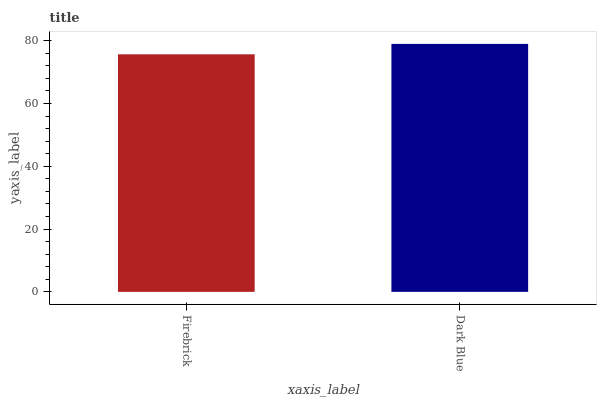Is Firebrick the minimum?
Answer yes or no. Yes. Is Dark Blue the maximum?
Answer yes or no. Yes. Is Dark Blue the minimum?
Answer yes or no. No. Is Dark Blue greater than Firebrick?
Answer yes or no. Yes. Is Firebrick less than Dark Blue?
Answer yes or no. Yes. Is Firebrick greater than Dark Blue?
Answer yes or no. No. Is Dark Blue less than Firebrick?
Answer yes or no. No. Is Dark Blue the high median?
Answer yes or no. Yes. Is Firebrick the low median?
Answer yes or no. Yes. Is Firebrick the high median?
Answer yes or no. No. Is Dark Blue the low median?
Answer yes or no. No. 